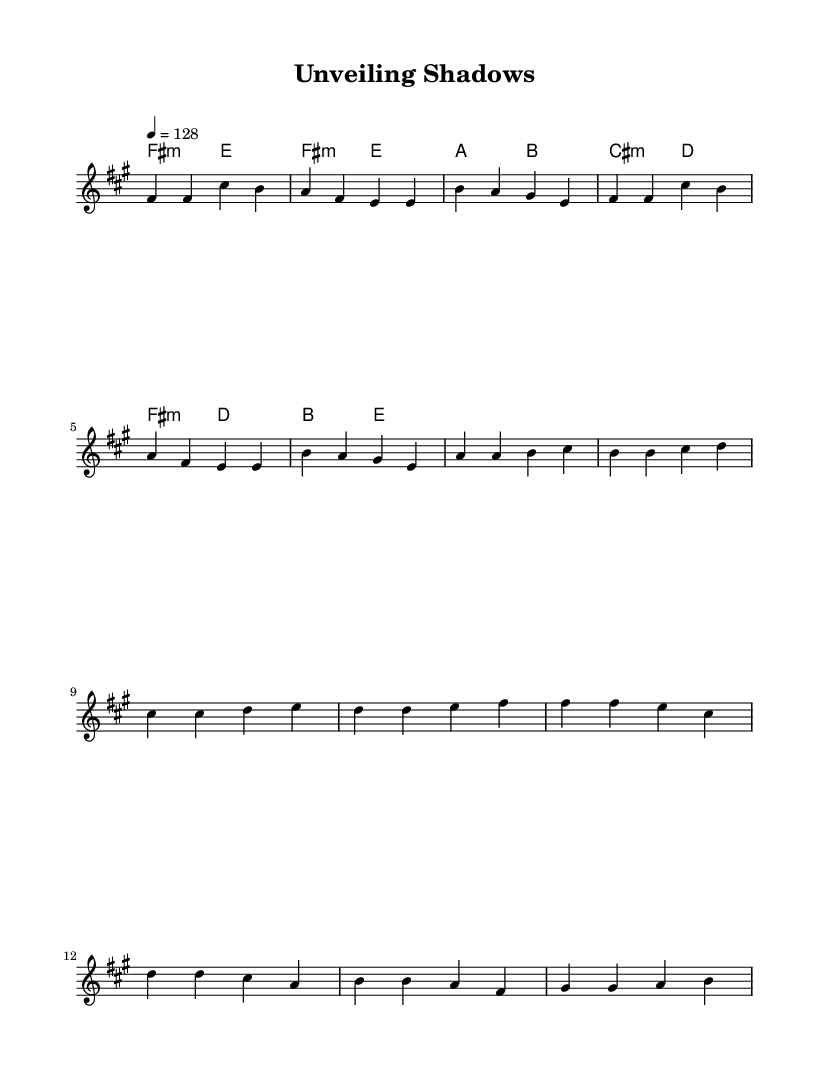What is the key signature of this music? The key signature is indicated by the "fis" which signifies that there are three sharps: F sharp, C sharp, and G sharp in the scale used.
Answer: F sharp minor What is the time signature of this music? The time signature displayed in the music sheet is "4/4," indicating there are four beats in each measure.
Answer: 4/4 What is the tempo of this music? The tempo is marked as "4 = 128," which refers to the beats per minute that should be played at the speed of 128.
Answer: 128 How many sections are in this piece? The music consists of three distinct sections: Verse, Pre-chorus, and Chorus – each identifiable in the layout.
Answer: Three What is the main theme of the lyrics? The lyrics indicate a theme of mystery and revelation, focusing on uncovering secrets and bringing hidden truths to light, as seen in the phrases and word choices.
Answer: Unveiling shadows How does the chord progression change between sections? The chord progression alters from F sharp minor in the verse to A and B in the pre-chorus, then returns to F sharp minor, indicating variations and tension throughout the song.
Answer: F sharp minor to A and B What is the significance of the repeated phrases in the lyrics? The repetition of phrases like "Unveiling shadows" in the chorus serves to emphasize the core message of revelation and truth, making it a powerful motif throughout the song.
Answer: Emphasis on revelation 